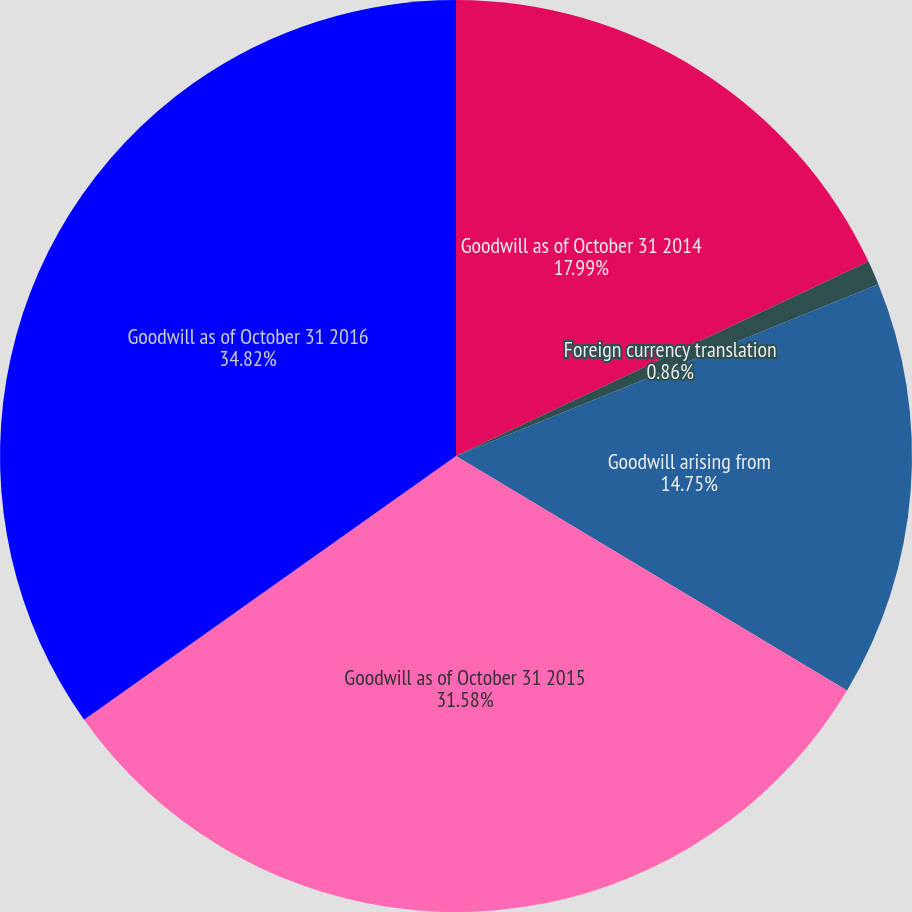Convert chart to OTSL. <chart><loc_0><loc_0><loc_500><loc_500><pie_chart><fcel>Goodwill as of October 31 2014<fcel>Foreign currency translation<fcel>Goodwill arising from<fcel>Goodwill as of October 31 2015<fcel>Goodwill as of October 31 2016<nl><fcel>17.99%<fcel>0.86%<fcel>14.75%<fcel>31.58%<fcel>34.82%<nl></chart> 